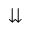<formula> <loc_0><loc_0><loc_500><loc_500>\downdownarrows</formula> 